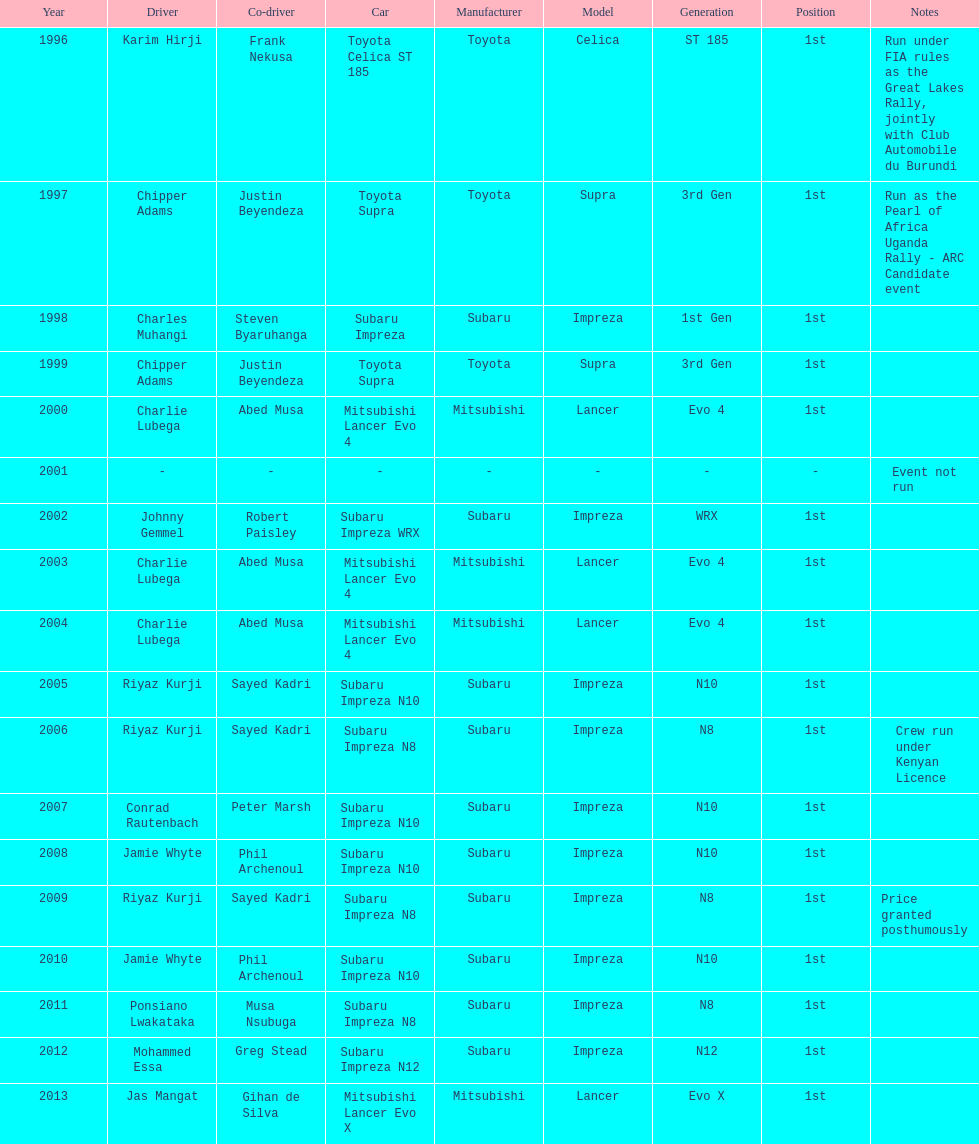How many times was a mitsubishi lancer the winning car before the year 2004? 2. 